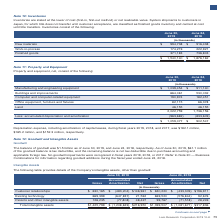According to Lam Research Corporation's financial document, What is the depreciation expense, including amortization of capital leases, during fiscal year 2019? According to the financial document, $182.1 million. The relevant text states: "ses, during fiscal years 2019, 2018, and 2017, was $182.1 million, $165.2 million, and $152.3 million, respectively...." Also, What is the Manufacturing and engineering equipment amount as of June 30, 2019? According to the financial document, $1,039,454 (in thousands). The relevant text states: "Manufacturing and engineering equipment $ 1,039,454 $ 911,140..." Also, What is the buildings and improvements amount as of June 30, 2019? According to the financial document, 664,061 (in thousands). The relevant text states: "Buildings and improvements 664,061 530,032..." Also, can you calculate: What is the percentage change in the Depreciation expense, including amortization of capital leases, from 2018 to 2019? To answer this question, I need to perform calculations using the financial data. The calculation is: (182.1-165.2)/165.2, which equals 10.23 (percentage). This is based on the information: "years 2019, 2018, and 2017, was $182.1 million, $165.2 million, and $152.3 million, respectively. s, during fiscal years 2019, 2018, and 2017, was $182.1 million, $165.2 million, and $152.3 million, r..." The key data points involved are: 165.2, 182.1. Also, can you calculate: What is the percentage change in the accumulated depreciation and amortization from 2018 to 2019? To answer this question, I need to perform calculations using the financial data. The calculation is: (963,682-833,609)/833,609, which equals 15.6 (percentage). This is based on the information: "umulated depreciation and amortization (963,682) (833,609) Less: accumulated depreciation and amortization (963,682) (833,609)..." The key data points involved are: 833,609, 963,682. Additionally, in which year is the net amount of property and equipment higher? According to the financial document, 2019. The relevant text states: "June 30, 2019 June 24, 2018..." 